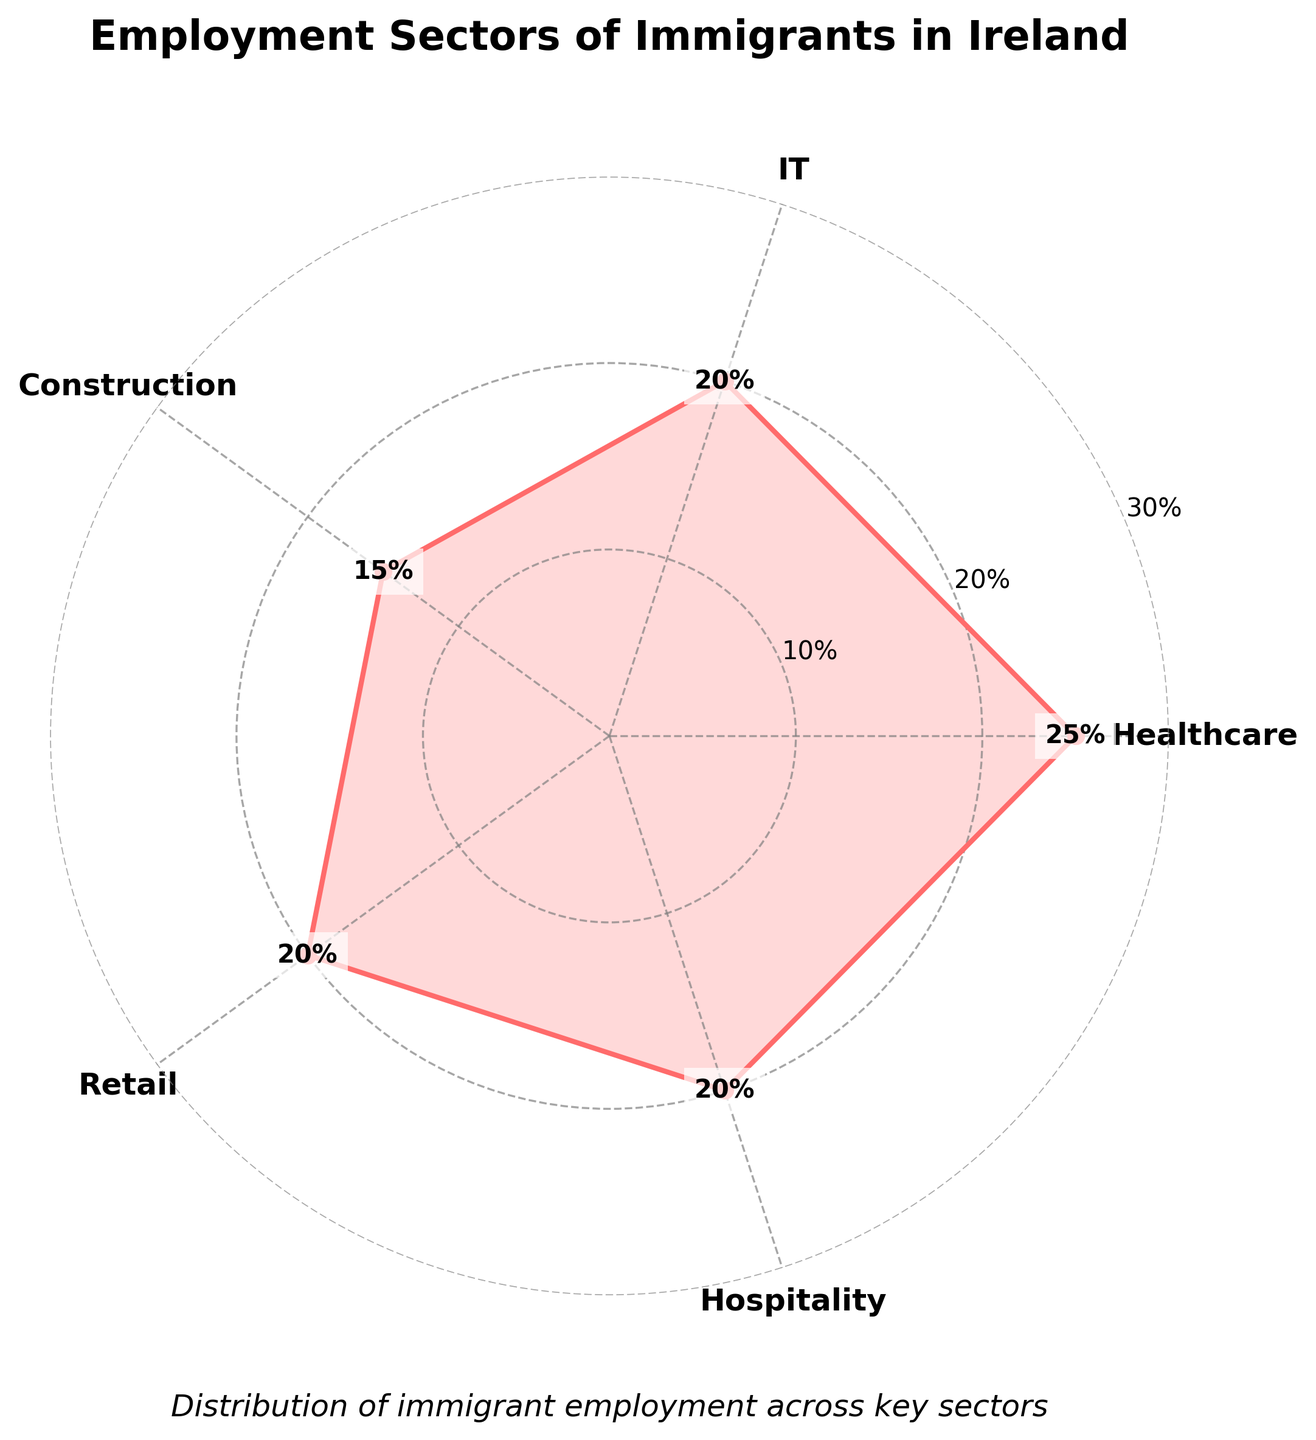What is the title of the radar chart? The title is usually displayed at the top center of the radar chart and provides a brief description of what the chart represents. In this case, it should summarize the key focus of the chart.
Answer: Employment Sectors of Immigrants in Ireland What is the percentage of immigrants working in the Healthcare sector? The percentage is directly labeled on the chart. Look at the Healthcare sector's position on the radar and see the value marked at the end of its line.
Answer: 25% Which employment sectors have equal percentages of immigrant workers? Examine the radar chart's lines where they intersect at the same radial distance from the center. Identify the sectors with the same length lines.
Answer: IT, Retail, and Hospitality Which sector has the smallest percentage of immigrant workers? Identify the sector with the shortest line on the radar chart. Verify by checking the percentage labels.
Answer: Construction What percentage of immigrants work in the Retail and IT sectors combined? Sum the percentages of immigrants in each of these sectors. Retail has 20%, and IT also has 20%. The combined total is 20% + 20%.
Answer: 40% How does the percentage of immigrants in the Construction sector compare with those in Healthcare? Compare the lines representing these two sectors. Note their labeled values and find the difference. Construction has 15%, Healthcare 25%.
Answer: Healthcare has 10% more Which sector has the highest percentage of immigrant workers? Identify the sector with the longest line extending from the center of the radar chart. Verify by checking the percentage labels.
Answer: Healthcare What is the difference in percentage points between the sector with the highest percentage and the sector with the smallest percentage? Identify the highest percentage (Healthcare with 25%) and smallest (Construction with 15%), then calculate the difference (25% - 15%).
Answer: 10% How many sectors are represented in the radar chart? Count the number of unique categories or labels shown on the radar chart. Each sector should be represented by a different labeled segment.
Answer: 5 What is the average percentage of immigrant workers across all sectors? Sum all sector percentages (25 + 20 + 15 + 20 + 20), then divide by the number of sectors (5). (100 / 5)
Answer: 20% 